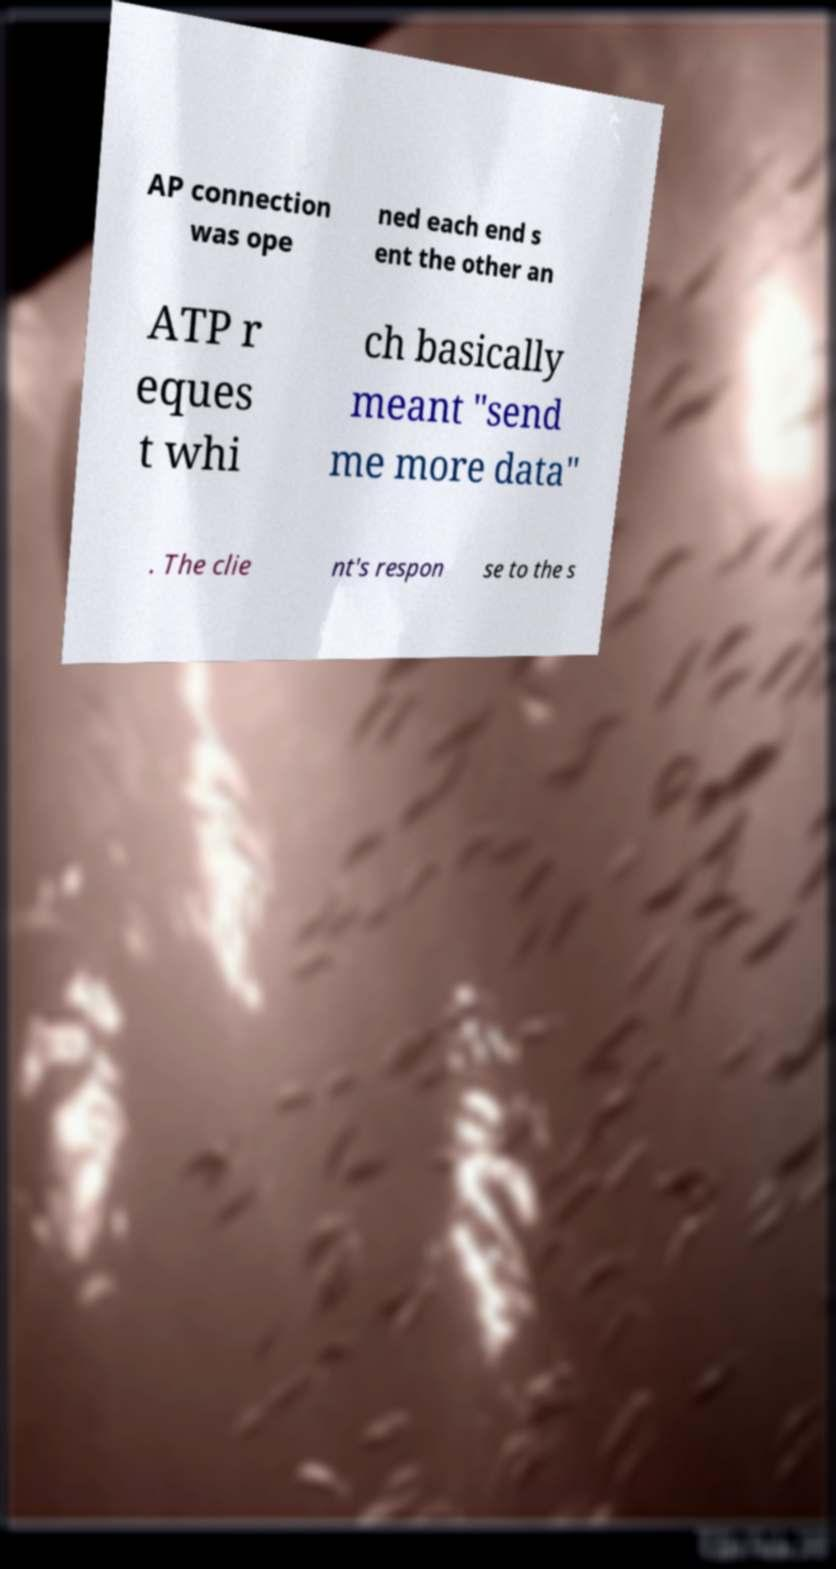There's text embedded in this image that I need extracted. Can you transcribe it verbatim? AP connection was ope ned each end s ent the other an ATP r eques t whi ch basically meant "send me more data" . The clie nt's respon se to the s 